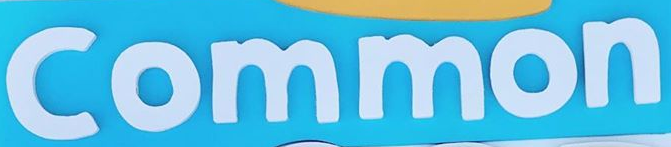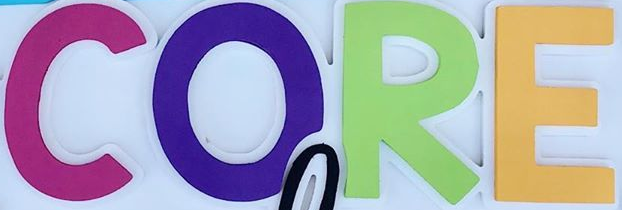What text appears in these images from left to right, separated by a semicolon? Common; CORE 